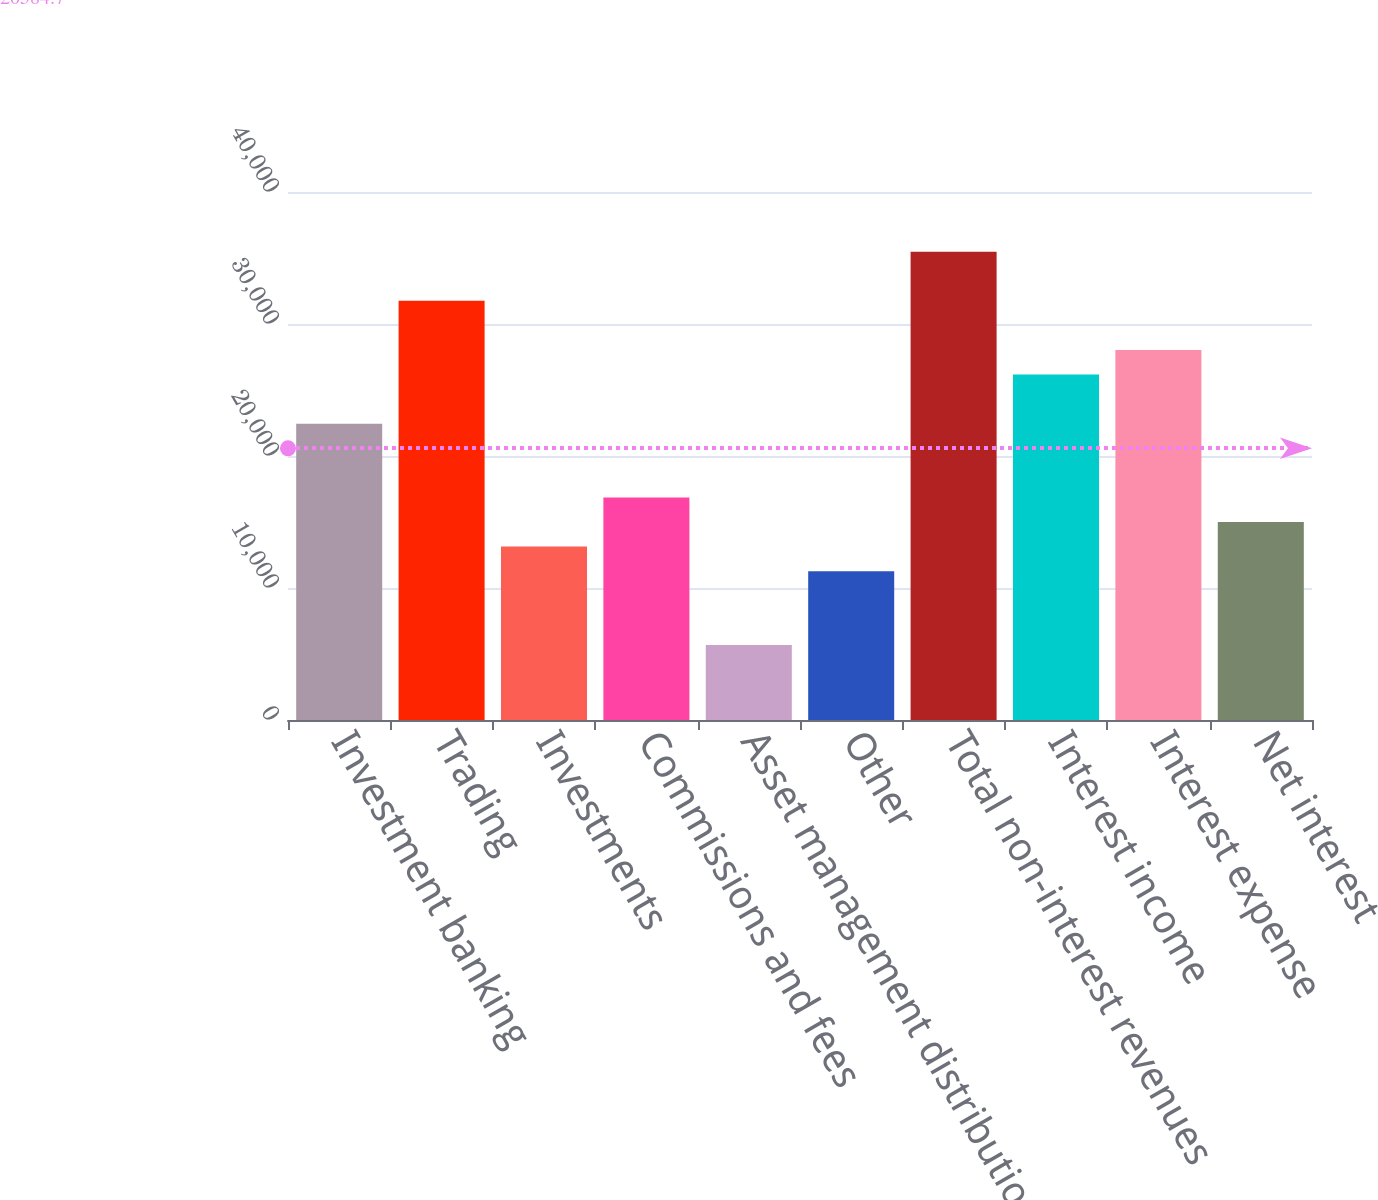Convert chart to OTSL. <chart><loc_0><loc_0><loc_500><loc_500><bar_chart><fcel>Investment banking<fcel>Trading<fcel>Investments<fcel>Commissions and fees<fcel>Asset management distribution<fcel>Other<fcel>Total non-interest revenues<fcel>Interest income<fcel>Interest expense<fcel>Net interest<nl><fcel>22446.4<fcel>31754.9<fcel>13137.9<fcel>16861.3<fcel>5691.1<fcel>11276.2<fcel>35478.3<fcel>26169.8<fcel>28031.5<fcel>14999.6<nl></chart> 